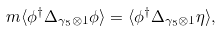Convert formula to latex. <formula><loc_0><loc_0><loc_500><loc_500>m \langle \phi ^ { \dagger } { \Delta _ { \gamma _ { 5 } \otimes { 1 } } } \phi \rangle = \langle \phi ^ { \dagger } { \Delta _ { \gamma _ { 5 } \otimes { 1 } } } \eta \rangle ,</formula> 